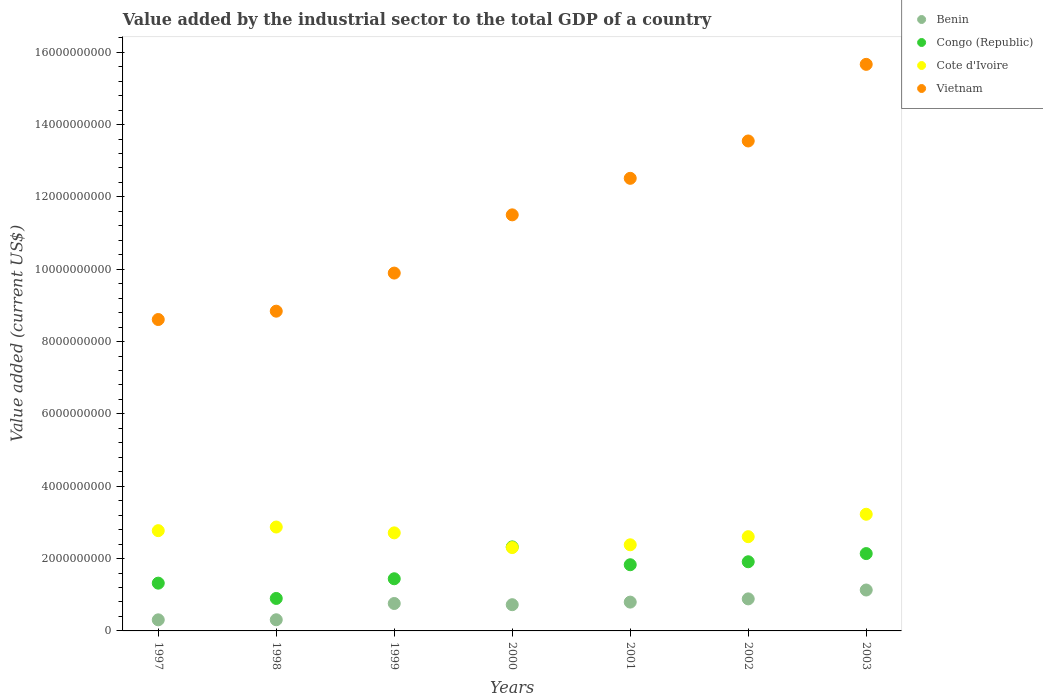How many different coloured dotlines are there?
Offer a terse response. 4. Is the number of dotlines equal to the number of legend labels?
Your answer should be compact. Yes. What is the value added by the industrial sector to the total GDP in Benin in 1997?
Provide a succinct answer. 3.07e+08. Across all years, what is the maximum value added by the industrial sector to the total GDP in Cote d'Ivoire?
Provide a short and direct response. 3.23e+09. Across all years, what is the minimum value added by the industrial sector to the total GDP in Cote d'Ivoire?
Provide a succinct answer. 2.30e+09. In which year was the value added by the industrial sector to the total GDP in Benin minimum?
Ensure brevity in your answer.  1997. What is the total value added by the industrial sector to the total GDP in Benin in the graph?
Your response must be concise. 4.91e+09. What is the difference between the value added by the industrial sector to the total GDP in Cote d'Ivoire in 1999 and that in 2002?
Your answer should be compact. 1.06e+08. What is the difference between the value added by the industrial sector to the total GDP in Cote d'Ivoire in 2003 and the value added by the industrial sector to the total GDP in Congo (Republic) in 2001?
Give a very brief answer. 1.40e+09. What is the average value added by the industrial sector to the total GDP in Vietnam per year?
Ensure brevity in your answer.  1.15e+1. In the year 1998, what is the difference between the value added by the industrial sector to the total GDP in Benin and value added by the industrial sector to the total GDP in Cote d'Ivoire?
Keep it short and to the point. -2.56e+09. What is the ratio of the value added by the industrial sector to the total GDP in Congo (Republic) in 1998 to that in 2000?
Keep it short and to the point. 0.39. Is the value added by the industrial sector to the total GDP in Benin in 1997 less than that in 2000?
Your answer should be compact. Yes. Is the difference between the value added by the industrial sector to the total GDP in Benin in 1999 and 2003 greater than the difference between the value added by the industrial sector to the total GDP in Cote d'Ivoire in 1999 and 2003?
Provide a short and direct response. Yes. What is the difference between the highest and the second highest value added by the industrial sector to the total GDP in Benin?
Offer a very short reply. 2.45e+08. What is the difference between the highest and the lowest value added by the industrial sector to the total GDP in Benin?
Give a very brief answer. 8.24e+08. Is the value added by the industrial sector to the total GDP in Congo (Republic) strictly greater than the value added by the industrial sector to the total GDP in Benin over the years?
Provide a short and direct response. Yes. Is the value added by the industrial sector to the total GDP in Congo (Republic) strictly less than the value added by the industrial sector to the total GDP in Cote d'Ivoire over the years?
Offer a terse response. No. How many dotlines are there?
Provide a succinct answer. 4. How many years are there in the graph?
Provide a short and direct response. 7. Does the graph contain any zero values?
Ensure brevity in your answer.  No. Where does the legend appear in the graph?
Offer a very short reply. Top right. How are the legend labels stacked?
Provide a short and direct response. Vertical. What is the title of the graph?
Your response must be concise. Value added by the industrial sector to the total GDP of a country. Does "Sierra Leone" appear as one of the legend labels in the graph?
Provide a short and direct response. No. What is the label or title of the X-axis?
Give a very brief answer. Years. What is the label or title of the Y-axis?
Ensure brevity in your answer.  Value added (current US$). What is the Value added (current US$) of Benin in 1997?
Provide a short and direct response. 3.07e+08. What is the Value added (current US$) of Congo (Republic) in 1997?
Give a very brief answer. 1.32e+09. What is the Value added (current US$) of Cote d'Ivoire in 1997?
Your answer should be very brief. 2.77e+09. What is the Value added (current US$) in Vietnam in 1997?
Make the answer very short. 8.61e+09. What is the Value added (current US$) in Benin in 1998?
Ensure brevity in your answer.  3.09e+08. What is the Value added (current US$) in Congo (Republic) in 1998?
Make the answer very short. 8.98e+08. What is the Value added (current US$) of Cote d'Ivoire in 1998?
Keep it short and to the point. 2.87e+09. What is the Value added (current US$) in Vietnam in 1998?
Provide a succinct answer. 8.84e+09. What is the Value added (current US$) of Benin in 1999?
Make the answer very short. 7.58e+08. What is the Value added (current US$) in Congo (Republic) in 1999?
Your response must be concise. 1.44e+09. What is the Value added (current US$) in Cote d'Ivoire in 1999?
Make the answer very short. 2.71e+09. What is the Value added (current US$) in Vietnam in 1999?
Keep it short and to the point. 9.89e+09. What is the Value added (current US$) of Benin in 2000?
Your answer should be very brief. 7.25e+08. What is the Value added (current US$) of Congo (Republic) in 2000?
Offer a terse response. 2.32e+09. What is the Value added (current US$) in Cote d'Ivoire in 2000?
Offer a terse response. 2.30e+09. What is the Value added (current US$) in Vietnam in 2000?
Provide a succinct answer. 1.15e+1. What is the Value added (current US$) of Benin in 2001?
Provide a succinct answer. 7.97e+08. What is the Value added (current US$) of Congo (Republic) in 2001?
Your answer should be very brief. 1.83e+09. What is the Value added (current US$) of Cote d'Ivoire in 2001?
Give a very brief answer. 2.38e+09. What is the Value added (current US$) of Vietnam in 2001?
Make the answer very short. 1.25e+1. What is the Value added (current US$) of Benin in 2002?
Make the answer very short. 8.86e+08. What is the Value added (current US$) in Congo (Republic) in 2002?
Offer a terse response. 1.91e+09. What is the Value added (current US$) of Cote d'Ivoire in 2002?
Your response must be concise. 2.61e+09. What is the Value added (current US$) in Vietnam in 2002?
Your answer should be very brief. 1.35e+1. What is the Value added (current US$) of Benin in 2003?
Your response must be concise. 1.13e+09. What is the Value added (current US$) of Congo (Republic) in 2003?
Keep it short and to the point. 2.14e+09. What is the Value added (current US$) in Cote d'Ivoire in 2003?
Provide a short and direct response. 3.23e+09. What is the Value added (current US$) in Vietnam in 2003?
Your answer should be very brief. 1.57e+1. Across all years, what is the maximum Value added (current US$) of Benin?
Your answer should be very brief. 1.13e+09. Across all years, what is the maximum Value added (current US$) in Congo (Republic)?
Make the answer very short. 2.32e+09. Across all years, what is the maximum Value added (current US$) of Cote d'Ivoire?
Provide a succinct answer. 3.23e+09. Across all years, what is the maximum Value added (current US$) in Vietnam?
Offer a very short reply. 1.57e+1. Across all years, what is the minimum Value added (current US$) in Benin?
Make the answer very short. 3.07e+08. Across all years, what is the minimum Value added (current US$) in Congo (Republic)?
Give a very brief answer. 8.98e+08. Across all years, what is the minimum Value added (current US$) of Cote d'Ivoire?
Ensure brevity in your answer.  2.30e+09. Across all years, what is the minimum Value added (current US$) in Vietnam?
Provide a succinct answer. 8.61e+09. What is the total Value added (current US$) of Benin in the graph?
Offer a terse response. 4.91e+09. What is the total Value added (current US$) in Congo (Republic) in the graph?
Your answer should be very brief. 1.19e+1. What is the total Value added (current US$) in Cote d'Ivoire in the graph?
Give a very brief answer. 1.89e+1. What is the total Value added (current US$) of Vietnam in the graph?
Your answer should be very brief. 8.06e+1. What is the difference between the Value added (current US$) of Benin in 1997 and that in 1998?
Make the answer very short. -1.83e+06. What is the difference between the Value added (current US$) in Congo (Republic) in 1997 and that in 1998?
Your answer should be compact. 4.23e+08. What is the difference between the Value added (current US$) in Cote d'Ivoire in 1997 and that in 1998?
Your answer should be compact. -1.00e+08. What is the difference between the Value added (current US$) in Vietnam in 1997 and that in 1998?
Your response must be concise. -2.31e+08. What is the difference between the Value added (current US$) of Benin in 1997 and that in 1999?
Your response must be concise. -4.52e+08. What is the difference between the Value added (current US$) in Congo (Republic) in 1997 and that in 1999?
Make the answer very short. -1.21e+08. What is the difference between the Value added (current US$) in Cote d'Ivoire in 1997 and that in 1999?
Your answer should be very brief. 6.10e+07. What is the difference between the Value added (current US$) in Vietnam in 1997 and that in 1999?
Offer a terse response. -1.28e+09. What is the difference between the Value added (current US$) of Benin in 1997 and that in 2000?
Your response must be concise. -4.18e+08. What is the difference between the Value added (current US$) of Congo (Republic) in 1997 and that in 2000?
Provide a short and direct response. -1.00e+09. What is the difference between the Value added (current US$) in Cote d'Ivoire in 1997 and that in 2000?
Make the answer very short. 4.68e+08. What is the difference between the Value added (current US$) of Vietnam in 1997 and that in 2000?
Provide a succinct answer. -2.89e+09. What is the difference between the Value added (current US$) of Benin in 1997 and that in 2001?
Provide a short and direct response. -4.90e+08. What is the difference between the Value added (current US$) in Congo (Republic) in 1997 and that in 2001?
Keep it short and to the point. -5.09e+08. What is the difference between the Value added (current US$) in Cote d'Ivoire in 1997 and that in 2001?
Keep it short and to the point. 3.91e+08. What is the difference between the Value added (current US$) in Vietnam in 1997 and that in 2001?
Offer a very short reply. -3.90e+09. What is the difference between the Value added (current US$) of Benin in 1997 and that in 2002?
Make the answer very short. -5.79e+08. What is the difference between the Value added (current US$) in Congo (Republic) in 1997 and that in 2002?
Offer a very short reply. -5.91e+08. What is the difference between the Value added (current US$) in Cote d'Ivoire in 1997 and that in 2002?
Offer a very short reply. 1.67e+08. What is the difference between the Value added (current US$) in Vietnam in 1997 and that in 2002?
Your answer should be very brief. -4.94e+09. What is the difference between the Value added (current US$) of Benin in 1997 and that in 2003?
Provide a short and direct response. -8.24e+08. What is the difference between the Value added (current US$) of Congo (Republic) in 1997 and that in 2003?
Offer a terse response. -8.18e+08. What is the difference between the Value added (current US$) in Cote d'Ivoire in 1997 and that in 2003?
Keep it short and to the point. -4.53e+08. What is the difference between the Value added (current US$) in Vietnam in 1997 and that in 2003?
Your response must be concise. -7.06e+09. What is the difference between the Value added (current US$) in Benin in 1998 and that in 1999?
Keep it short and to the point. -4.50e+08. What is the difference between the Value added (current US$) of Congo (Republic) in 1998 and that in 1999?
Give a very brief answer. -5.44e+08. What is the difference between the Value added (current US$) in Cote d'Ivoire in 1998 and that in 1999?
Offer a very short reply. 1.61e+08. What is the difference between the Value added (current US$) of Vietnam in 1998 and that in 1999?
Your answer should be very brief. -1.05e+09. What is the difference between the Value added (current US$) in Benin in 1998 and that in 2000?
Provide a short and direct response. -4.17e+08. What is the difference between the Value added (current US$) in Congo (Republic) in 1998 and that in 2000?
Keep it short and to the point. -1.43e+09. What is the difference between the Value added (current US$) of Cote d'Ivoire in 1998 and that in 2000?
Ensure brevity in your answer.  5.68e+08. What is the difference between the Value added (current US$) in Vietnam in 1998 and that in 2000?
Offer a very short reply. -2.66e+09. What is the difference between the Value added (current US$) in Benin in 1998 and that in 2001?
Provide a succinct answer. -4.88e+08. What is the difference between the Value added (current US$) in Congo (Republic) in 1998 and that in 2001?
Offer a terse response. -9.32e+08. What is the difference between the Value added (current US$) in Cote d'Ivoire in 1998 and that in 2001?
Your answer should be very brief. 4.91e+08. What is the difference between the Value added (current US$) in Vietnam in 1998 and that in 2001?
Give a very brief answer. -3.67e+09. What is the difference between the Value added (current US$) in Benin in 1998 and that in 2002?
Your response must be concise. -5.77e+08. What is the difference between the Value added (current US$) of Congo (Republic) in 1998 and that in 2002?
Provide a succinct answer. -1.01e+09. What is the difference between the Value added (current US$) in Cote d'Ivoire in 1998 and that in 2002?
Ensure brevity in your answer.  2.67e+08. What is the difference between the Value added (current US$) in Vietnam in 1998 and that in 2002?
Your response must be concise. -4.71e+09. What is the difference between the Value added (current US$) in Benin in 1998 and that in 2003?
Provide a short and direct response. -8.23e+08. What is the difference between the Value added (current US$) of Congo (Republic) in 1998 and that in 2003?
Provide a short and direct response. -1.24e+09. What is the difference between the Value added (current US$) in Cote d'Ivoire in 1998 and that in 2003?
Offer a terse response. -3.53e+08. What is the difference between the Value added (current US$) of Vietnam in 1998 and that in 2003?
Your response must be concise. -6.82e+09. What is the difference between the Value added (current US$) of Benin in 1999 and that in 2000?
Give a very brief answer. 3.35e+07. What is the difference between the Value added (current US$) of Congo (Republic) in 1999 and that in 2000?
Ensure brevity in your answer.  -8.81e+08. What is the difference between the Value added (current US$) of Cote d'Ivoire in 1999 and that in 2000?
Ensure brevity in your answer.  4.07e+08. What is the difference between the Value added (current US$) of Vietnam in 1999 and that in 2000?
Keep it short and to the point. -1.61e+09. What is the difference between the Value added (current US$) in Benin in 1999 and that in 2001?
Your response must be concise. -3.82e+07. What is the difference between the Value added (current US$) in Congo (Republic) in 1999 and that in 2001?
Your answer should be very brief. -3.88e+08. What is the difference between the Value added (current US$) in Cote d'Ivoire in 1999 and that in 2001?
Your answer should be compact. 3.30e+08. What is the difference between the Value added (current US$) of Vietnam in 1999 and that in 2001?
Your response must be concise. -2.62e+09. What is the difference between the Value added (current US$) of Benin in 1999 and that in 2002?
Make the answer very short. -1.27e+08. What is the difference between the Value added (current US$) in Congo (Republic) in 1999 and that in 2002?
Keep it short and to the point. -4.70e+08. What is the difference between the Value added (current US$) in Cote d'Ivoire in 1999 and that in 2002?
Offer a very short reply. 1.06e+08. What is the difference between the Value added (current US$) of Vietnam in 1999 and that in 2002?
Make the answer very short. -3.65e+09. What is the difference between the Value added (current US$) of Benin in 1999 and that in 2003?
Your answer should be compact. -3.73e+08. What is the difference between the Value added (current US$) of Congo (Republic) in 1999 and that in 2003?
Offer a terse response. -6.96e+08. What is the difference between the Value added (current US$) of Cote d'Ivoire in 1999 and that in 2003?
Offer a very short reply. -5.14e+08. What is the difference between the Value added (current US$) in Vietnam in 1999 and that in 2003?
Ensure brevity in your answer.  -5.77e+09. What is the difference between the Value added (current US$) of Benin in 2000 and that in 2001?
Provide a succinct answer. -7.17e+07. What is the difference between the Value added (current US$) of Congo (Republic) in 2000 and that in 2001?
Your answer should be compact. 4.93e+08. What is the difference between the Value added (current US$) in Cote d'Ivoire in 2000 and that in 2001?
Give a very brief answer. -7.68e+07. What is the difference between the Value added (current US$) of Vietnam in 2000 and that in 2001?
Ensure brevity in your answer.  -1.01e+09. What is the difference between the Value added (current US$) in Benin in 2000 and that in 2002?
Give a very brief answer. -1.61e+08. What is the difference between the Value added (current US$) of Congo (Republic) in 2000 and that in 2002?
Make the answer very short. 4.11e+08. What is the difference between the Value added (current US$) of Cote d'Ivoire in 2000 and that in 2002?
Your answer should be very brief. -3.01e+08. What is the difference between the Value added (current US$) of Vietnam in 2000 and that in 2002?
Make the answer very short. -2.04e+09. What is the difference between the Value added (current US$) of Benin in 2000 and that in 2003?
Make the answer very short. -4.06e+08. What is the difference between the Value added (current US$) in Congo (Republic) in 2000 and that in 2003?
Keep it short and to the point. 1.85e+08. What is the difference between the Value added (current US$) of Cote d'Ivoire in 2000 and that in 2003?
Make the answer very short. -9.21e+08. What is the difference between the Value added (current US$) of Vietnam in 2000 and that in 2003?
Offer a very short reply. -4.16e+09. What is the difference between the Value added (current US$) of Benin in 2001 and that in 2002?
Offer a terse response. -8.91e+07. What is the difference between the Value added (current US$) of Congo (Republic) in 2001 and that in 2002?
Keep it short and to the point. -8.23e+07. What is the difference between the Value added (current US$) in Cote d'Ivoire in 2001 and that in 2002?
Make the answer very short. -2.24e+08. What is the difference between the Value added (current US$) in Vietnam in 2001 and that in 2002?
Provide a succinct answer. -1.03e+09. What is the difference between the Value added (current US$) of Benin in 2001 and that in 2003?
Provide a succinct answer. -3.34e+08. What is the difference between the Value added (current US$) in Congo (Republic) in 2001 and that in 2003?
Offer a terse response. -3.09e+08. What is the difference between the Value added (current US$) in Cote d'Ivoire in 2001 and that in 2003?
Keep it short and to the point. -8.44e+08. What is the difference between the Value added (current US$) of Vietnam in 2001 and that in 2003?
Provide a short and direct response. -3.15e+09. What is the difference between the Value added (current US$) of Benin in 2002 and that in 2003?
Give a very brief answer. -2.45e+08. What is the difference between the Value added (current US$) of Congo (Republic) in 2002 and that in 2003?
Make the answer very short. -2.26e+08. What is the difference between the Value added (current US$) of Cote d'Ivoire in 2002 and that in 2003?
Give a very brief answer. -6.20e+08. What is the difference between the Value added (current US$) of Vietnam in 2002 and that in 2003?
Your answer should be very brief. -2.12e+09. What is the difference between the Value added (current US$) of Benin in 1997 and the Value added (current US$) of Congo (Republic) in 1998?
Offer a terse response. -5.91e+08. What is the difference between the Value added (current US$) of Benin in 1997 and the Value added (current US$) of Cote d'Ivoire in 1998?
Your answer should be very brief. -2.57e+09. What is the difference between the Value added (current US$) in Benin in 1997 and the Value added (current US$) in Vietnam in 1998?
Provide a short and direct response. -8.53e+09. What is the difference between the Value added (current US$) in Congo (Republic) in 1997 and the Value added (current US$) in Cote d'Ivoire in 1998?
Provide a short and direct response. -1.55e+09. What is the difference between the Value added (current US$) of Congo (Republic) in 1997 and the Value added (current US$) of Vietnam in 1998?
Provide a succinct answer. -7.52e+09. What is the difference between the Value added (current US$) of Cote d'Ivoire in 1997 and the Value added (current US$) of Vietnam in 1998?
Your response must be concise. -6.07e+09. What is the difference between the Value added (current US$) of Benin in 1997 and the Value added (current US$) of Congo (Republic) in 1999?
Provide a succinct answer. -1.14e+09. What is the difference between the Value added (current US$) of Benin in 1997 and the Value added (current US$) of Cote d'Ivoire in 1999?
Keep it short and to the point. -2.40e+09. What is the difference between the Value added (current US$) in Benin in 1997 and the Value added (current US$) in Vietnam in 1999?
Give a very brief answer. -9.59e+09. What is the difference between the Value added (current US$) in Congo (Republic) in 1997 and the Value added (current US$) in Cote d'Ivoire in 1999?
Offer a terse response. -1.39e+09. What is the difference between the Value added (current US$) of Congo (Republic) in 1997 and the Value added (current US$) of Vietnam in 1999?
Make the answer very short. -8.57e+09. What is the difference between the Value added (current US$) of Cote d'Ivoire in 1997 and the Value added (current US$) of Vietnam in 1999?
Keep it short and to the point. -7.12e+09. What is the difference between the Value added (current US$) of Benin in 1997 and the Value added (current US$) of Congo (Republic) in 2000?
Keep it short and to the point. -2.02e+09. What is the difference between the Value added (current US$) of Benin in 1997 and the Value added (current US$) of Cote d'Ivoire in 2000?
Ensure brevity in your answer.  -2.00e+09. What is the difference between the Value added (current US$) in Benin in 1997 and the Value added (current US$) in Vietnam in 2000?
Make the answer very short. -1.12e+1. What is the difference between the Value added (current US$) of Congo (Republic) in 1997 and the Value added (current US$) of Cote d'Ivoire in 2000?
Offer a terse response. -9.84e+08. What is the difference between the Value added (current US$) of Congo (Republic) in 1997 and the Value added (current US$) of Vietnam in 2000?
Offer a very short reply. -1.02e+1. What is the difference between the Value added (current US$) of Cote d'Ivoire in 1997 and the Value added (current US$) of Vietnam in 2000?
Your answer should be very brief. -8.73e+09. What is the difference between the Value added (current US$) in Benin in 1997 and the Value added (current US$) in Congo (Republic) in 2001?
Provide a succinct answer. -1.52e+09. What is the difference between the Value added (current US$) of Benin in 1997 and the Value added (current US$) of Cote d'Ivoire in 2001?
Provide a succinct answer. -2.07e+09. What is the difference between the Value added (current US$) in Benin in 1997 and the Value added (current US$) in Vietnam in 2001?
Make the answer very short. -1.22e+1. What is the difference between the Value added (current US$) of Congo (Republic) in 1997 and the Value added (current US$) of Cote d'Ivoire in 2001?
Provide a short and direct response. -1.06e+09. What is the difference between the Value added (current US$) in Congo (Republic) in 1997 and the Value added (current US$) in Vietnam in 2001?
Your answer should be compact. -1.12e+1. What is the difference between the Value added (current US$) in Cote d'Ivoire in 1997 and the Value added (current US$) in Vietnam in 2001?
Give a very brief answer. -9.74e+09. What is the difference between the Value added (current US$) of Benin in 1997 and the Value added (current US$) of Congo (Republic) in 2002?
Your answer should be very brief. -1.61e+09. What is the difference between the Value added (current US$) of Benin in 1997 and the Value added (current US$) of Cote d'Ivoire in 2002?
Provide a succinct answer. -2.30e+09. What is the difference between the Value added (current US$) of Benin in 1997 and the Value added (current US$) of Vietnam in 2002?
Your answer should be very brief. -1.32e+1. What is the difference between the Value added (current US$) of Congo (Republic) in 1997 and the Value added (current US$) of Cote d'Ivoire in 2002?
Make the answer very short. -1.28e+09. What is the difference between the Value added (current US$) of Congo (Republic) in 1997 and the Value added (current US$) of Vietnam in 2002?
Your answer should be very brief. -1.22e+1. What is the difference between the Value added (current US$) in Cote d'Ivoire in 1997 and the Value added (current US$) in Vietnam in 2002?
Give a very brief answer. -1.08e+1. What is the difference between the Value added (current US$) of Benin in 1997 and the Value added (current US$) of Congo (Republic) in 2003?
Make the answer very short. -1.83e+09. What is the difference between the Value added (current US$) of Benin in 1997 and the Value added (current US$) of Cote d'Ivoire in 2003?
Make the answer very short. -2.92e+09. What is the difference between the Value added (current US$) in Benin in 1997 and the Value added (current US$) in Vietnam in 2003?
Your answer should be compact. -1.54e+1. What is the difference between the Value added (current US$) of Congo (Republic) in 1997 and the Value added (current US$) of Cote d'Ivoire in 2003?
Give a very brief answer. -1.90e+09. What is the difference between the Value added (current US$) in Congo (Republic) in 1997 and the Value added (current US$) in Vietnam in 2003?
Provide a short and direct response. -1.43e+1. What is the difference between the Value added (current US$) in Cote d'Ivoire in 1997 and the Value added (current US$) in Vietnam in 2003?
Keep it short and to the point. -1.29e+1. What is the difference between the Value added (current US$) of Benin in 1998 and the Value added (current US$) of Congo (Republic) in 1999?
Give a very brief answer. -1.13e+09. What is the difference between the Value added (current US$) of Benin in 1998 and the Value added (current US$) of Cote d'Ivoire in 1999?
Your answer should be compact. -2.40e+09. What is the difference between the Value added (current US$) in Benin in 1998 and the Value added (current US$) in Vietnam in 1999?
Your response must be concise. -9.59e+09. What is the difference between the Value added (current US$) in Congo (Republic) in 1998 and the Value added (current US$) in Cote d'Ivoire in 1999?
Provide a short and direct response. -1.81e+09. What is the difference between the Value added (current US$) of Congo (Republic) in 1998 and the Value added (current US$) of Vietnam in 1999?
Your answer should be very brief. -9.00e+09. What is the difference between the Value added (current US$) of Cote d'Ivoire in 1998 and the Value added (current US$) of Vietnam in 1999?
Provide a short and direct response. -7.02e+09. What is the difference between the Value added (current US$) of Benin in 1998 and the Value added (current US$) of Congo (Republic) in 2000?
Provide a short and direct response. -2.01e+09. What is the difference between the Value added (current US$) of Benin in 1998 and the Value added (current US$) of Cote d'Ivoire in 2000?
Keep it short and to the point. -2.00e+09. What is the difference between the Value added (current US$) of Benin in 1998 and the Value added (current US$) of Vietnam in 2000?
Make the answer very short. -1.12e+1. What is the difference between the Value added (current US$) of Congo (Republic) in 1998 and the Value added (current US$) of Cote d'Ivoire in 2000?
Your answer should be compact. -1.41e+09. What is the difference between the Value added (current US$) of Congo (Republic) in 1998 and the Value added (current US$) of Vietnam in 2000?
Offer a terse response. -1.06e+1. What is the difference between the Value added (current US$) in Cote d'Ivoire in 1998 and the Value added (current US$) in Vietnam in 2000?
Offer a very short reply. -8.63e+09. What is the difference between the Value added (current US$) in Benin in 1998 and the Value added (current US$) in Congo (Republic) in 2001?
Your answer should be very brief. -1.52e+09. What is the difference between the Value added (current US$) in Benin in 1998 and the Value added (current US$) in Cote d'Ivoire in 2001?
Offer a very short reply. -2.07e+09. What is the difference between the Value added (current US$) in Benin in 1998 and the Value added (current US$) in Vietnam in 2001?
Provide a succinct answer. -1.22e+1. What is the difference between the Value added (current US$) in Congo (Republic) in 1998 and the Value added (current US$) in Cote d'Ivoire in 2001?
Your answer should be very brief. -1.48e+09. What is the difference between the Value added (current US$) in Congo (Republic) in 1998 and the Value added (current US$) in Vietnam in 2001?
Your response must be concise. -1.16e+1. What is the difference between the Value added (current US$) in Cote d'Ivoire in 1998 and the Value added (current US$) in Vietnam in 2001?
Offer a terse response. -9.64e+09. What is the difference between the Value added (current US$) in Benin in 1998 and the Value added (current US$) in Congo (Republic) in 2002?
Provide a short and direct response. -1.60e+09. What is the difference between the Value added (current US$) in Benin in 1998 and the Value added (current US$) in Cote d'Ivoire in 2002?
Your answer should be very brief. -2.30e+09. What is the difference between the Value added (current US$) of Benin in 1998 and the Value added (current US$) of Vietnam in 2002?
Give a very brief answer. -1.32e+1. What is the difference between the Value added (current US$) of Congo (Republic) in 1998 and the Value added (current US$) of Cote d'Ivoire in 2002?
Make the answer very short. -1.71e+09. What is the difference between the Value added (current US$) in Congo (Republic) in 1998 and the Value added (current US$) in Vietnam in 2002?
Provide a succinct answer. -1.26e+1. What is the difference between the Value added (current US$) of Cote d'Ivoire in 1998 and the Value added (current US$) of Vietnam in 2002?
Provide a succinct answer. -1.07e+1. What is the difference between the Value added (current US$) of Benin in 1998 and the Value added (current US$) of Congo (Republic) in 2003?
Your answer should be compact. -1.83e+09. What is the difference between the Value added (current US$) in Benin in 1998 and the Value added (current US$) in Cote d'Ivoire in 2003?
Make the answer very short. -2.92e+09. What is the difference between the Value added (current US$) of Benin in 1998 and the Value added (current US$) of Vietnam in 2003?
Offer a very short reply. -1.54e+1. What is the difference between the Value added (current US$) in Congo (Republic) in 1998 and the Value added (current US$) in Cote d'Ivoire in 2003?
Your answer should be compact. -2.33e+09. What is the difference between the Value added (current US$) of Congo (Republic) in 1998 and the Value added (current US$) of Vietnam in 2003?
Give a very brief answer. -1.48e+1. What is the difference between the Value added (current US$) of Cote d'Ivoire in 1998 and the Value added (current US$) of Vietnam in 2003?
Give a very brief answer. -1.28e+1. What is the difference between the Value added (current US$) in Benin in 1999 and the Value added (current US$) in Congo (Republic) in 2000?
Offer a very short reply. -1.56e+09. What is the difference between the Value added (current US$) in Benin in 1999 and the Value added (current US$) in Cote d'Ivoire in 2000?
Give a very brief answer. -1.55e+09. What is the difference between the Value added (current US$) of Benin in 1999 and the Value added (current US$) of Vietnam in 2000?
Give a very brief answer. -1.07e+1. What is the difference between the Value added (current US$) of Congo (Republic) in 1999 and the Value added (current US$) of Cote d'Ivoire in 2000?
Make the answer very short. -8.62e+08. What is the difference between the Value added (current US$) in Congo (Republic) in 1999 and the Value added (current US$) in Vietnam in 2000?
Offer a very short reply. -1.01e+1. What is the difference between the Value added (current US$) of Cote d'Ivoire in 1999 and the Value added (current US$) of Vietnam in 2000?
Give a very brief answer. -8.79e+09. What is the difference between the Value added (current US$) in Benin in 1999 and the Value added (current US$) in Congo (Republic) in 2001?
Offer a terse response. -1.07e+09. What is the difference between the Value added (current US$) of Benin in 1999 and the Value added (current US$) of Cote d'Ivoire in 2001?
Give a very brief answer. -1.62e+09. What is the difference between the Value added (current US$) of Benin in 1999 and the Value added (current US$) of Vietnam in 2001?
Offer a very short reply. -1.18e+1. What is the difference between the Value added (current US$) of Congo (Republic) in 1999 and the Value added (current US$) of Cote d'Ivoire in 2001?
Make the answer very short. -9.39e+08. What is the difference between the Value added (current US$) of Congo (Republic) in 1999 and the Value added (current US$) of Vietnam in 2001?
Your answer should be compact. -1.11e+1. What is the difference between the Value added (current US$) of Cote d'Ivoire in 1999 and the Value added (current US$) of Vietnam in 2001?
Keep it short and to the point. -9.80e+09. What is the difference between the Value added (current US$) in Benin in 1999 and the Value added (current US$) in Congo (Republic) in 2002?
Offer a very short reply. -1.15e+09. What is the difference between the Value added (current US$) in Benin in 1999 and the Value added (current US$) in Cote d'Ivoire in 2002?
Make the answer very short. -1.85e+09. What is the difference between the Value added (current US$) of Benin in 1999 and the Value added (current US$) of Vietnam in 2002?
Your answer should be very brief. -1.28e+1. What is the difference between the Value added (current US$) in Congo (Republic) in 1999 and the Value added (current US$) in Cote d'Ivoire in 2002?
Your answer should be very brief. -1.16e+09. What is the difference between the Value added (current US$) in Congo (Republic) in 1999 and the Value added (current US$) in Vietnam in 2002?
Make the answer very short. -1.21e+1. What is the difference between the Value added (current US$) in Cote d'Ivoire in 1999 and the Value added (current US$) in Vietnam in 2002?
Your answer should be compact. -1.08e+1. What is the difference between the Value added (current US$) of Benin in 1999 and the Value added (current US$) of Congo (Republic) in 2003?
Keep it short and to the point. -1.38e+09. What is the difference between the Value added (current US$) of Benin in 1999 and the Value added (current US$) of Cote d'Ivoire in 2003?
Provide a short and direct response. -2.47e+09. What is the difference between the Value added (current US$) of Benin in 1999 and the Value added (current US$) of Vietnam in 2003?
Your response must be concise. -1.49e+1. What is the difference between the Value added (current US$) of Congo (Republic) in 1999 and the Value added (current US$) of Cote d'Ivoire in 2003?
Your response must be concise. -1.78e+09. What is the difference between the Value added (current US$) of Congo (Republic) in 1999 and the Value added (current US$) of Vietnam in 2003?
Ensure brevity in your answer.  -1.42e+1. What is the difference between the Value added (current US$) of Cote d'Ivoire in 1999 and the Value added (current US$) of Vietnam in 2003?
Offer a very short reply. -1.30e+1. What is the difference between the Value added (current US$) in Benin in 2000 and the Value added (current US$) in Congo (Republic) in 2001?
Provide a short and direct response. -1.10e+09. What is the difference between the Value added (current US$) in Benin in 2000 and the Value added (current US$) in Cote d'Ivoire in 2001?
Give a very brief answer. -1.66e+09. What is the difference between the Value added (current US$) of Benin in 2000 and the Value added (current US$) of Vietnam in 2001?
Make the answer very short. -1.18e+1. What is the difference between the Value added (current US$) in Congo (Republic) in 2000 and the Value added (current US$) in Cote d'Ivoire in 2001?
Your answer should be very brief. -5.82e+07. What is the difference between the Value added (current US$) of Congo (Republic) in 2000 and the Value added (current US$) of Vietnam in 2001?
Ensure brevity in your answer.  -1.02e+1. What is the difference between the Value added (current US$) in Cote d'Ivoire in 2000 and the Value added (current US$) in Vietnam in 2001?
Give a very brief answer. -1.02e+1. What is the difference between the Value added (current US$) of Benin in 2000 and the Value added (current US$) of Congo (Republic) in 2002?
Provide a succinct answer. -1.19e+09. What is the difference between the Value added (current US$) in Benin in 2000 and the Value added (current US$) in Cote d'Ivoire in 2002?
Provide a succinct answer. -1.88e+09. What is the difference between the Value added (current US$) of Benin in 2000 and the Value added (current US$) of Vietnam in 2002?
Your answer should be compact. -1.28e+1. What is the difference between the Value added (current US$) of Congo (Republic) in 2000 and the Value added (current US$) of Cote d'Ivoire in 2002?
Your answer should be compact. -2.82e+08. What is the difference between the Value added (current US$) in Congo (Republic) in 2000 and the Value added (current US$) in Vietnam in 2002?
Give a very brief answer. -1.12e+1. What is the difference between the Value added (current US$) of Cote d'Ivoire in 2000 and the Value added (current US$) of Vietnam in 2002?
Make the answer very short. -1.12e+1. What is the difference between the Value added (current US$) of Benin in 2000 and the Value added (current US$) of Congo (Republic) in 2003?
Make the answer very short. -1.41e+09. What is the difference between the Value added (current US$) in Benin in 2000 and the Value added (current US$) in Cote d'Ivoire in 2003?
Provide a short and direct response. -2.50e+09. What is the difference between the Value added (current US$) of Benin in 2000 and the Value added (current US$) of Vietnam in 2003?
Provide a short and direct response. -1.49e+1. What is the difference between the Value added (current US$) of Congo (Republic) in 2000 and the Value added (current US$) of Cote d'Ivoire in 2003?
Your response must be concise. -9.02e+08. What is the difference between the Value added (current US$) of Congo (Republic) in 2000 and the Value added (current US$) of Vietnam in 2003?
Offer a very short reply. -1.33e+1. What is the difference between the Value added (current US$) of Cote d'Ivoire in 2000 and the Value added (current US$) of Vietnam in 2003?
Offer a terse response. -1.34e+1. What is the difference between the Value added (current US$) of Benin in 2001 and the Value added (current US$) of Congo (Republic) in 2002?
Offer a terse response. -1.12e+09. What is the difference between the Value added (current US$) of Benin in 2001 and the Value added (current US$) of Cote d'Ivoire in 2002?
Offer a very short reply. -1.81e+09. What is the difference between the Value added (current US$) in Benin in 2001 and the Value added (current US$) in Vietnam in 2002?
Make the answer very short. -1.28e+1. What is the difference between the Value added (current US$) of Congo (Republic) in 2001 and the Value added (current US$) of Cote d'Ivoire in 2002?
Your answer should be very brief. -7.76e+08. What is the difference between the Value added (current US$) of Congo (Republic) in 2001 and the Value added (current US$) of Vietnam in 2002?
Ensure brevity in your answer.  -1.17e+1. What is the difference between the Value added (current US$) of Cote d'Ivoire in 2001 and the Value added (current US$) of Vietnam in 2002?
Give a very brief answer. -1.12e+1. What is the difference between the Value added (current US$) in Benin in 2001 and the Value added (current US$) in Congo (Republic) in 2003?
Your answer should be compact. -1.34e+09. What is the difference between the Value added (current US$) of Benin in 2001 and the Value added (current US$) of Cote d'Ivoire in 2003?
Offer a very short reply. -2.43e+09. What is the difference between the Value added (current US$) of Benin in 2001 and the Value added (current US$) of Vietnam in 2003?
Your answer should be very brief. -1.49e+1. What is the difference between the Value added (current US$) of Congo (Republic) in 2001 and the Value added (current US$) of Cote d'Ivoire in 2003?
Give a very brief answer. -1.40e+09. What is the difference between the Value added (current US$) in Congo (Republic) in 2001 and the Value added (current US$) in Vietnam in 2003?
Ensure brevity in your answer.  -1.38e+1. What is the difference between the Value added (current US$) of Cote d'Ivoire in 2001 and the Value added (current US$) of Vietnam in 2003?
Make the answer very short. -1.33e+1. What is the difference between the Value added (current US$) in Benin in 2002 and the Value added (current US$) in Congo (Republic) in 2003?
Offer a very short reply. -1.25e+09. What is the difference between the Value added (current US$) in Benin in 2002 and the Value added (current US$) in Cote d'Ivoire in 2003?
Provide a short and direct response. -2.34e+09. What is the difference between the Value added (current US$) of Benin in 2002 and the Value added (current US$) of Vietnam in 2003?
Your answer should be very brief. -1.48e+1. What is the difference between the Value added (current US$) in Congo (Republic) in 2002 and the Value added (current US$) in Cote d'Ivoire in 2003?
Give a very brief answer. -1.31e+09. What is the difference between the Value added (current US$) in Congo (Republic) in 2002 and the Value added (current US$) in Vietnam in 2003?
Offer a very short reply. -1.38e+1. What is the difference between the Value added (current US$) in Cote d'Ivoire in 2002 and the Value added (current US$) in Vietnam in 2003?
Make the answer very short. -1.31e+1. What is the average Value added (current US$) in Benin per year?
Keep it short and to the point. 7.02e+08. What is the average Value added (current US$) in Congo (Republic) per year?
Make the answer very short. 1.69e+09. What is the average Value added (current US$) of Cote d'Ivoire per year?
Your answer should be very brief. 2.70e+09. What is the average Value added (current US$) of Vietnam per year?
Offer a terse response. 1.15e+1. In the year 1997, what is the difference between the Value added (current US$) in Benin and Value added (current US$) in Congo (Republic)?
Make the answer very short. -1.01e+09. In the year 1997, what is the difference between the Value added (current US$) of Benin and Value added (current US$) of Cote d'Ivoire?
Provide a short and direct response. -2.47e+09. In the year 1997, what is the difference between the Value added (current US$) in Benin and Value added (current US$) in Vietnam?
Offer a terse response. -8.30e+09. In the year 1997, what is the difference between the Value added (current US$) of Congo (Republic) and Value added (current US$) of Cote d'Ivoire?
Offer a very short reply. -1.45e+09. In the year 1997, what is the difference between the Value added (current US$) in Congo (Republic) and Value added (current US$) in Vietnam?
Provide a succinct answer. -7.29e+09. In the year 1997, what is the difference between the Value added (current US$) in Cote d'Ivoire and Value added (current US$) in Vietnam?
Keep it short and to the point. -5.84e+09. In the year 1998, what is the difference between the Value added (current US$) in Benin and Value added (current US$) in Congo (Republic)?
Offer a terse response. -5.89e+08. In the year 1998, what is the difference between the Value added (current US$) in Benin and Value added (current US$) in Cote d'Ivoire?
Ensure brevity in your answer.  -2.56e+09. In the year 1998, what is the difference between the Value added (current US$) in Benin and Value added (current US$) in Vietnam?
Provide a short and direct response. -8.53e+09. In the year 1998, what is the difference between the Value added (current US$) in Congo (Republic) and Value added (current US$) in Cote d'Ivoire?
Offer a very short reply. -1.97e+09. In the year 1998, what is the difference between the Value added (current US$) in Congo (Republic) and Value added (current US$) in Vietnam?
Give a very brief answer. -7.94e+09. In the year 1998, what is the difference between the Value added (current US$) of Cote d'Ivoire and Value added (current US$) of Vietnam?
Offer a very short reply. -5.97e+09. In the year 1999, what is the difference between the Value added (current US$) in Benin and Value added (current US$) in Congo (Republic)?
Keep it short and to the point. -6.84e+08. In the year 1999, what is the difference between the Value added (current US$) in Benin and Value added (current US$) in Cote d'Ivoire?
Ensure brevity in your answer.  -1.95e+09. In the year 1999, what is the difference between the Value added (current US$) in Benin and Value added (current US$) in Vietnam?
Keep it short and to the point. -9.14e+09. In the year 1999, what is the difference between the Value added (current US$) of Congo (Republic) and Value added (current US$) of Cote d'Ivoire?
Your response must be concise. -1.27e+09. In the year 1999, what is the difference between the Value added (current US$) in Congo (Republic) and Value added (current US$) in Vietnam?
Your response must be concise. -8.45e+09. In the year 1999, what is the difference between the Value added (current US$) of Cote d'Ivoire and Value added (current US$) of Vietnam?
Give a very brief answer. -7.18e+09. In the year 2000, what is the difference between the Value added (current US$) of Benin and Value added (current US$) of Congo (Republic)?
Your answer should be very brief. -1.60e+09. In the year 2000, what is the difference between the Value added (current US$) of Benin and Value added (current US$) of Cote d'Ivoire?
Provide a short and direct response. -1.58e+09. In the year 2000, what is the difference between the Value added (current US$) in Benin and Value added (current US$) in Vietnam?
Your response must be concise. -1.08e+1. In the year 2000, what is the difference between the Value added (current US$) in Congo (Republic) and Value added (current US$) in Cote d'Ivoire?
Provide a succinct answer. 1.86e+07. In the year 2000, what is the difference between the Value added (current US$) in Congo (Republic) and Value added (current US$) in Vietnam?
Provide a short and direct response. -9.18e+09. In the year 2000, what is the difference between the Value added (current US$) of Cote d'Ivoire and Value added (current US$) of Vietnam?
Offer a very short reply. -9.20e+09. In the year 2001, what is the difference between the Value added (current US$) in Benin and Value added (current US$) in Congo (Republic)?
Your answer should be compact. -1.03e+09. In the year 2001, what is the difference between the Value added (current US$) in Benin and Value added (current US$) in Cote d'Ivoire?
Offer a very short reply. -1.58e+09. In the year 2001, what is the difference between the Value added (current US$) in Benin and Value added (current US$) in Vietnam?
Your answer should be very brief. -1.17e+1. In the year 2001, what is the difference between the Value added (current US$) of Congo (Republic) and Value added (current US$) of Cote d'Ivoire?
Provide a short and direct response. -5.52e+08. In the year 2001, what is the difference between the Value added (current US$) in Congo (Republic) and Value added (current US$) in Vietnam?
Make the answer very short. -1.07e+1. In the year 2001, what is the difference between the Value added (current US$) of Cote d'Ivoire and Value added (current US$) of Vietnam?
Offer a very short reply. -1.01e+1. In the year 2002, what is the difference between the Value added (current US$) of Benin and Value added (current US$) of Congo (Republic)?
Give a very brief answer. -1.03e+09. In the year 2002, what is the difference between the Value added (current US$) of Benin and Value added (current US$) of Cote d'Ivoire?
Offer a terse response. -1.72e+09. In the year 2002, what is the difference between the Value added (current US$) of Benin and Value added (current US$) of Vietnam?
Make the answer very short. -1.27e+1. In the year 2002, what is the difference between the Value added (current US$) of Congo (Republic) and Value added (current US$) of Cote d'Ivoire?
Your response must be concise. -6.93e+08. In the year 2002, what is the difference between the Value added (current US$) of Congo (Republic) and Value added (current US$) of Vietnam?
Offer a terse response. -1.16e+1. In the year 2002, what is the difference between the Value added (current US$) in Cote d'Ivoire and Value added (current US$) in Vietnam?
Offer a terse response. -1.09e+1. In the year 2003, what is the difference between the Value added (current US$) of Benin and Value added (current US$) of Congo (Republic)?
Give a very brief answer. -1.01e+09. In the year 2003, what is the difference between the Value added (current US$) in Benin and Value added (current US$) in Cote d'Ivoire?
Provide a succinct answer. -2.09e+09. In the year 2003, what is the difference between the Value added (current US$) in Benin and Value added (current US$) in Vietnam?
Your answer should be compact. -1.45e+1. In the year 2003, what is the difference between the Value added (current US$) of Congo (Republic) and Value added (current US$) of Cote d'Ivoire?
Your answer should be very brief. -1.09e+09. In the year 2003, what is the difference between the Value added (current US$) of Congo (Republic) and Value added (current US$) of Vietnam?
Give a very brief answer. -1.35e+1. In the year 2003, what is the difference between the Value added (current US$) of Cote d'Ivoire and Value added (current US$) of Vietnam?
Offer a very short reply. -1.24e+1. What is the ratio of the Value added (current US$) of Congo (Republic) in 1997 to that in 1998?
Ensure brevity in your answer.  1.47. What is the ratio of the Value added (current US$) of Cote d'Ivoire in 1997 to that in 1998?
Your answer should be very brief. 0.96. What is the ratio of the Value added (current US$) in Vietnam in 1997 to that in 1998?
Provide a short and direct response. 0.97. What is the ratio of the Value added (current US$) in Benin in 1997 to that in 1999?
Offer a terse response. 0.4. What is the ratio of the Value added (current US$) in Congo (Republic) in 1997 to that in 1999?
Keep it short and to the point. 0.92. What is the ratio of the Value added (current US$) in Cote d'Ivoire in 1997 to that in 1999?
Offer a terse response. 1.02. What is the ratio of the Value added (current US$) of Vietnam in 1997 to that in 1999?
Offer a terse response. 0.87. What is the ratio of the Value added (current US$) in Benin in 1997 to that in 2000?
Give a very brief answer. 0.42. What is the ratio of the Value added (current US$) of Congo (Republic) in 1997 to that in 2000?
Ensure brevity in your answer.  0.57. What is the ratio of the Value added (current US$) of Cote d'Ivoire in 1997 to that in 2000?
Make the answer very short. 1.2. What is the ratio of the Value added (current US$) of Vietnam in 1997 to that in 2000?
Provide a short and direct response. 0.75. What is the ratio of the Value added (current US$) in Benin in 1997 to that in 2001?
Offer a terse response. 0.39. What is the ratio of the Value added (current US$) in Congo (Republic) in 1997 to that in 2001?
Your answer should be compact. 0.72. What is the ratio of the Value added (current US$) of Cote d'Ivoire in 1997 to that in 2001?
Keep it short and to the point. 1.16. What is the ratio of the Value added (current US$) of Vietnam in 1997 to that in 2001?
Provide a short and direct response. 0.69. What is the ratio of the Value added (current US$) in Benin in 1997 to that in 2002?
Give a very brief answer. 0.35. What is the ratio of the Value added (current US$) in Congo (Republic) in 1997 to that in 2002?
Provide a succinct answer. 0.69. What is the ratio of the Value added (current US$) of Cote d'Ivoire in 1997 to that in 2002?
Your answer should be very brief. 1.06. What is the ratio of the Value added (current US$) of Vietnam in 1997 to that in 2002?
Provide a short and direct response. 0.64. What is the ratio of the Value added (current US$) of Benin in 1997 to that in 2003?
Offer a terse response. 0.27. What is the ratio of the Value added (current US$) in Congo (Republic) in 1997 to that in 2003?
Give a very brief answer. 0.62. What is the ratio of the Value added (current US$) in Cote d'Ivoire in 1997 to that in 2003?
Your response must be concise. 0.86. What is the ratio of the Value added (current US$) in Vietnam in 1997 to that in 2003?
Offer a very short reply. 0.55. What is the ratio of the Value added (current US$) of Benin in 1998 to that in 1999?
Make the answer very short. 0.41. What is the ratio of the Value added (current US$) of Congo (Republic) in 1998 to that in 1999?
Ensure brevity in your answer.  0.62. What is the ratio of the Value added (current US$) in Cote d'Ivoire in 1998 to that in 1999?
Provide a short and direct response. 1.06. What is the ratio of the Value added (current US$) in Vietnam in 1998 to that in 1999?
Ensure brevity in your answer.  0.89. What is the ratio of the Value added (current US$) in Benin in 1998 to that in 2000?
Your response must be concise. 0.43. What is the ratio of the Value added (current US$) in Congo (Republic) in 1998 to that in 2000?
Offer a terse response. 0.39. What is the ratio of the Value added (current US$) of Cote d'Ivoire in 1998 to that in 2000?
Offer a terse response. 1.25. What is the ratio of the Value added (current US$) in Vietnam in 1998 to that in 2000?
Offer a terse response. 0.77. What is the ratio of the Value added (current US$) in Benin in 1998 to that in 2001?
Ensure brevity in your answer.  0.39. What is the ratio of the Value added (current US$) in Congo (Republic) in 1998 to that in 2001?
Make the answer very short. 0.49. What is the ratio of the Value added (current US$) of Cote d'Ivoire in 1998 to that in 2001?
Keep it short and to the point. 1.21. What is the ratio of the Value added (current US$) in Vietnam in 1998 to that in 2001?
Your answer should be very brief. 0.71. What is the ratio of the Value added (current US$) in Benin in 1998 to that in 2002?
Make the answer very short. 0.35. What is the ratio of the Value added (current US$) in Congo (Republic) in 1998 to that in 2002?
Offer a very short reply. 0.47. What is the ratio of the Value added (current US$) in Cote d'Ivoire in 1998 to that in 2002?
Offer a very short reply. 1.1. What is the ratio of the Value added (current US$) in Vietnam in 1998 to that in 2002?
Offer a terse response. 0.65. What is the ratio of the Value added (current US$) in Benin in 1998 to that in 2003?
Provide a succinct answer. 0.27. What is the ratio of the Value added (current US$) of Congo (Republic) in 1998 to that in 2003?
Your answer should be compact. 0.42. What is the ratio of the Value added (current US$) of Cote d'Ivoire in 1998 to that in 2003?
Provide a short and direct response. 0.89. What is the ratio of the Value added (current US$) of Vietnam in 1998 to that in 2003?
Provide a short and direct response. 0.56. What is the ratio of the Value added (current US$) of Benin in 1999 to that in 2000?
Ensure brevity in your answer.  1.05. What is the ratio of the Value added (current US$) in Congo (Republic) in 1999 to that in 2000?
Ensure brevity in your answer.  0.62. What is the ratio of the Value added (current US$) in Cote d'Ivoire in 1999 to that in 2000?
Ensure brevity in your answer.  1.18. What is the ratio of the Value added (current US$) in Vietnam in 1999 to that in 2000?
Offer a terse response. 0.86. What is the ratio of the Value added (current US$) in Benin in 1999 to that in 2001?
Make the answer very short. 0.95. What is the ratio of the Value added (current US$) in Congo (Republic) in 1999 to that in 2001?
Your answer should be very brief. 0.79. What is the ratio of the Value added (current US$) of Cote d'Ivoire in 1999 to that in 2001?
Provide a short and direct response. 1.14. What is the ratio of the Value added (current US$) in Vietnam in 1999 to that in 2001?
Offer a very short reply. 0.79. What is the ratio of the Value added (current US$) of Benin in 1999 to that in 2002?
Offer a very short reply. 0.86. What is the ratio of the Value added (current US$) in Congo (Republic) in 1999 to that in 2002?
Keep it short and to the point. 0.75. What is the ratio of the Value added (current US$) in Cote d'Ivoire in 1999 to that in 2002?
Provide a short and direct response. 1.04. What is the ratio of the Value added (current US$) of Vietnam in 1999 to that in 2002?
Make the answer very short. 0.73. What is the ratio of the Value added (current US$) of Benin in 1999 to that in 2003?
Give a very brief answer. 0.67. What is the ratio of the Value added (current US$) of Congo (Republic) in 1999 to that in 2003?
Provide a succinct answer. 0.67. What is the ratio of the Value added (current US$) of Cote d'Ivoire in 1999 to that in 2003?
Make the answer very short. 0.84. What is the ratio of the Value added (current US$) in Vietnam in 1999 to that in 2003?
Give a very brief answer. 0.63. What is the ratio of the Value added (current US$) in Benin in 2000 to that in 2001?
Provide a succinct answer. 0.91. What is the ratio of the Value added (current US$) of Congo (Republic) in 2000 to that in 2001?
Keep it short and to the point. 1.27. What is the ratio of the Value added (current US$) in Cote d'Ivoire in 2000 to that in 2001?
Keep it short and to the point. 0.97. What is the ratio of the Value added (current US$) of Vietnam in 2000 to that in 2001?
Offer a terse response. 0.92. What is the ratio of the Value added (current US$) of Benin in 2000 to that in 2002?
Your answer should be compact. 0.82. What is the ratio of the Value added (current US$) in Congo (Republic) in 2000 to that in 2002?
Keep it short and to the point. 1.21. What is the ratio of the Value added (current US$) in Cote d'Ivoire in 2000 to that in 2002?
Ensure brevity in your answer.  0.88. What is the ratio of the Value added (current US$) of Vietnam in 2000 to that in 2002?
Provide a short and direct response. 0.85. What is the ratio of the Value added (current US$) in Benin in 2000 to that in 2003?
Give a very brief answer. 0.64. What is the ratio of the Value added (current US$) of Congo (Republic) in 2000 to that in 2003?
Provide a succinct answer. 1.09. What is the ratio of the Value added (current US$) in Cote d'Ivoire in 2000 to that in 2003?
Your response must be concise. 0.71. What is the ratio of the Value added (current US$) in Vietnam in 2000 to that in 2003?
Make the answer very short. 0.73. What is the ratio of the Value added (current US$) in Benin in 2001 to that in 2002?
Give a very brief answer. 0.9. What is the ratio of the Value added (current US$) in Cote d'Ivoire in 2001 to that in 2002?
Give a very brief answer. 0.91. What is the ratio of the Value added (current US$) of Vietnam in 2001 to that in 2002?
Make the answer very short. 0.92. What is the ratio of the Value added (current US$) of Benin in 2001 to that in 2003?
Make the answer very short. 0.7. What is the ratio of the Value added (current US$) of Congo (Republic) in 2001 to that in 2003?
Make the answer very short. 0.86. What is the ratio of the Value added (current US$) in Cote d'Ivoire in 2001 to that in 2003?
Ensure brevity in your answer.  0.74. What is the ratio of the Value added (current US$) in Vietnam in 2001 to that in 2003?
Your answer should be very brief. 0.8. What is the ratio of the Value added (current US$) of Benin in 2002 to that in 2003?
Provide a succinct answer. 0.78. What is the ratio of the Value added (current US$) in Congo (Republic) in 2002 to that in 2003?
Your answer should be very brief. 0.89. What is the ratio of the Value added (current US$) in Cote d'Ivoire in 2002 to that in 2003?
Make the answer very short. 0.81. What is the ratio of the Value added (current US$) in Vietnam in 2002 to that in 2003?
Keep it short and to the point. 0.86. What is the difference between the highest and the second highest Value added (current US$) of Benin?
Keep it short and to the point. 2.45e+08. What is the difference between the highest and the second highest Value added (current US$) in Congo (Republic)?
Ensure brevity in your answer.  1.85e+08. What is the difference between the highest and the second highest Value added (current US$) of Cote d'Ivoire?
Your response must be concise. 3.53e+08. What is the difference between the highest and the second highest Value added (current US$) of Vietnam?
Make the answer very short. 2.12e+09. What is the difference between the highest and the lowest Value added (current US$) of Benin?
Give a very brief answer. 8.24e+08. What is the difference between the highest and the lowest Value added (current US$) in Congo (Republic)?
Your response must be concise. 1.43e+09. What is the difference between the highest and the lowest Value added (current US$) of Cote d'Ivoire?
Offer a very short reply. 9.21e+08. What is the difference between the highest and the lowest Value added (current US$) of Vietnam?
Give a very brief answer. 7.06e+09. 